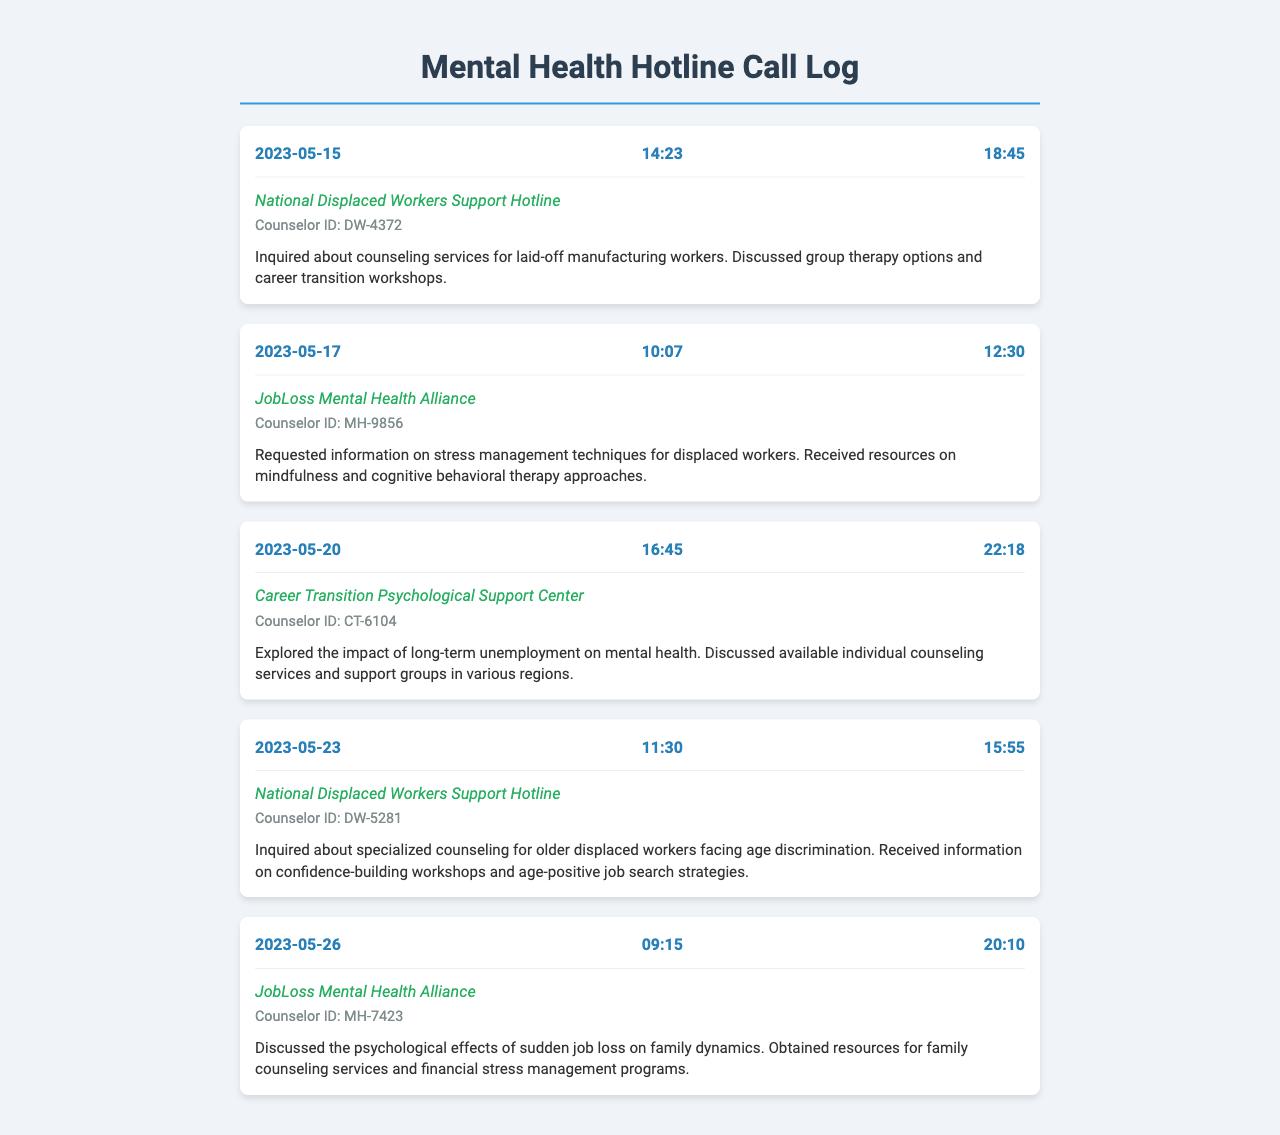what is the date of the first call? The date of the first call listed in the document is the earliest date entry, which is 2023-05-15.
Answer: 2023-05-15 what is the duration of the call on May 20, 2023? The duration of the call on May 20, 2023, is recorded in the document, which shows 22:18 as the time duration.
Answer: 22:18 which hotline was contacted on May 23, 2023? The document specifies the hotline contacted on May 23, 2023, which is the National Displaced Workers Support Hotline.
Answer: National Displaced Workers Support Hotline what was the main topic of the call on May 26, 2023? The main topic of the call on May 26, 2023, is indicated in the notes, detailing the psychological effects of sudden job loss on family dynamics.
Answer: psychological effects of sudden job loss on family dynamics how many different hotline services were contacted? The document lists calls to four different hotline services on different dates, which includes National Displaced Workers Support Hotline, JobLoss Mental Health Alliance, and Career Transition Psychological Support Center.
Answer: 4 what type of support was discussed in the call on May 17, 2023? The type of support discussed in the call on May 17, 2023, concerns stress management techniques for displaced workers.
Answer: stress management techniques what is the counselor ID associated with the call on May 15, 2023? The counselor ID associated with the call on May 15, 2023, is listed in the document as DW-4372.
Answer: DW-4372 